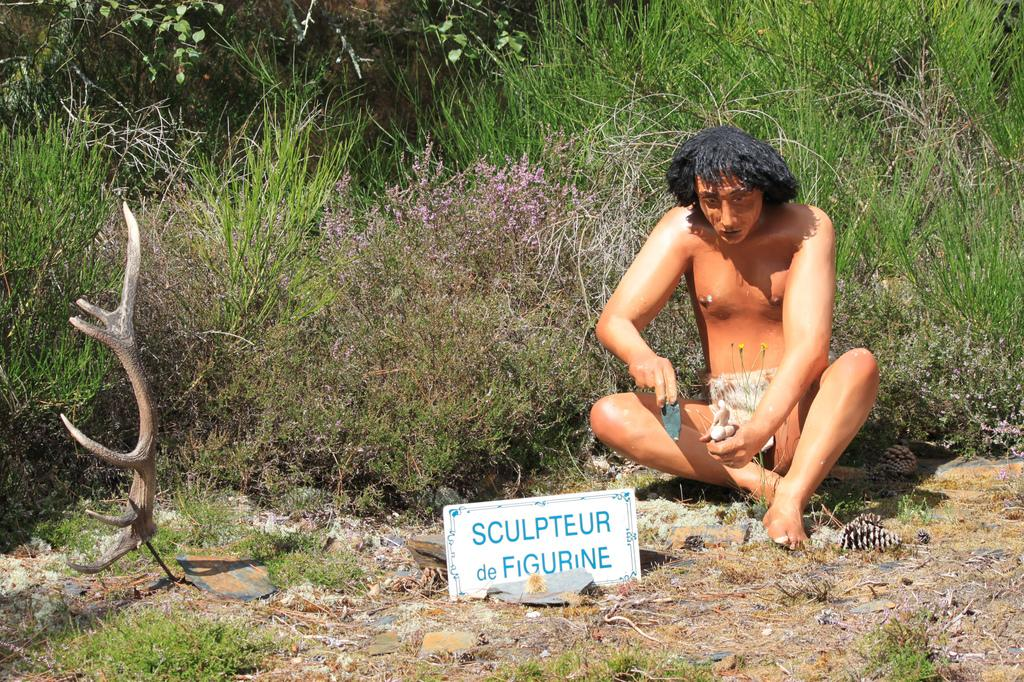What is the main subject of the image? There is a wooden statue of a man in the image. Where is the statue located in relation to other objects? The statue is placed near to boards. What type of natural environment is visible in the image? There is grass visible in the image. What type of vegetation is present in the image? There are plants in the image. What word does the statue use to congratulate the achiever in the image? There is no achiever or word present in the image; it only features a wooden statue of a man and some plants. 